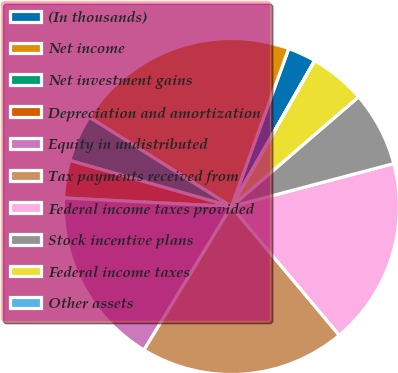Convert chart to OTSL. <chart><loc_0><loc_0><loc_500><loc_500><pie_chart><fcel>(In thousands)<fcel>Net income<fcel>Net investment gains<fcel>Depreciation and amortization<fcel>Equity in undistributed<fcel>Tax payments received from<fcel>Federal income taxes provided<fcel>Stock incentive plans<fcel>Federal income taxes<fcel>Other assets<nl><fcel>2.71%<fcel>21.62%<fcel>4.51%<fcel>3.61%<fcel>17.11%<fcel>19.81%<fcel>18.01%<fcel>7.21%<fcel>5.41%<fcel>0.01%<nl></chart> 